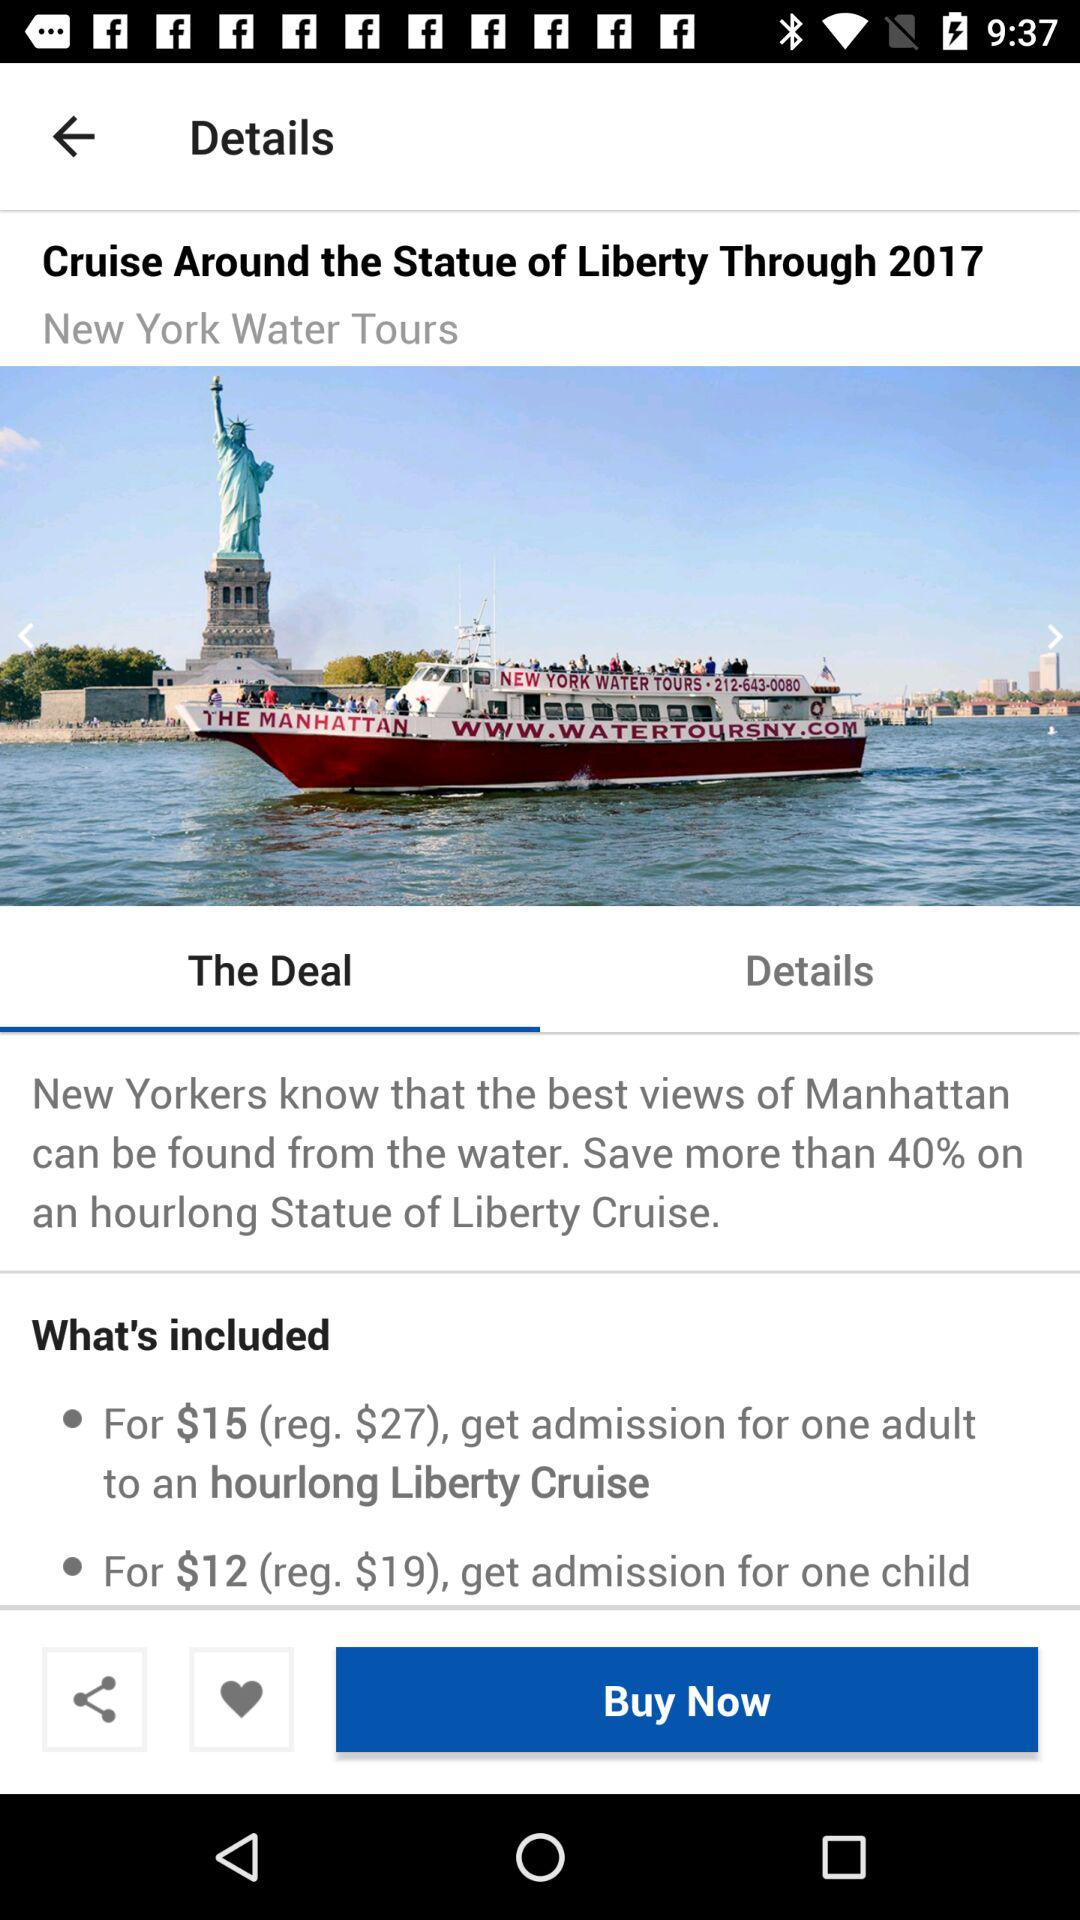How long is the trip to Ireland in the fall?
When the provided information is insufficient, respond with <no answer>. <no answer> 